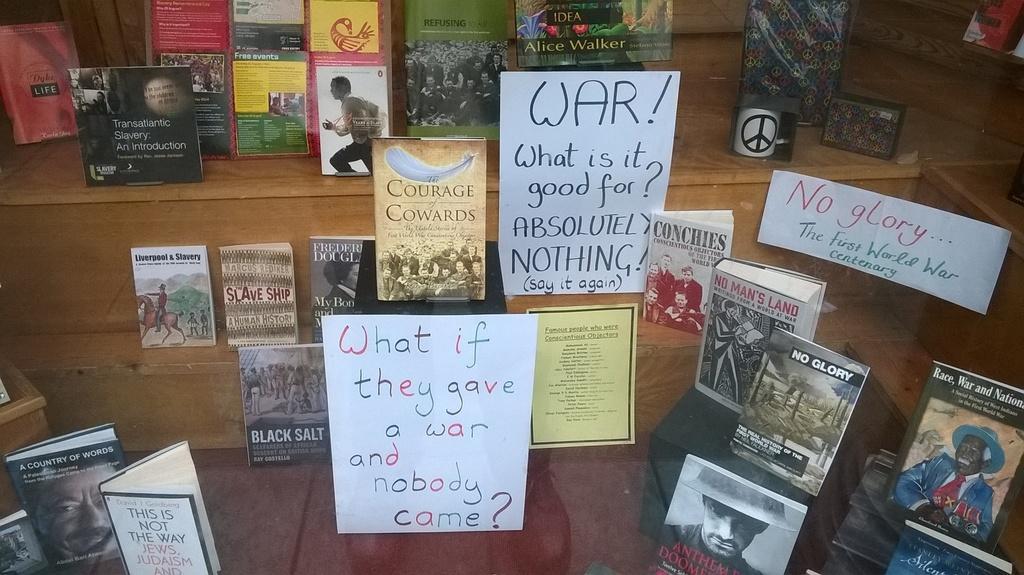How would you summarize this image in a sentence or two? Here we can see posts on the glass. In the background there are books on a platform in stepwise order. 